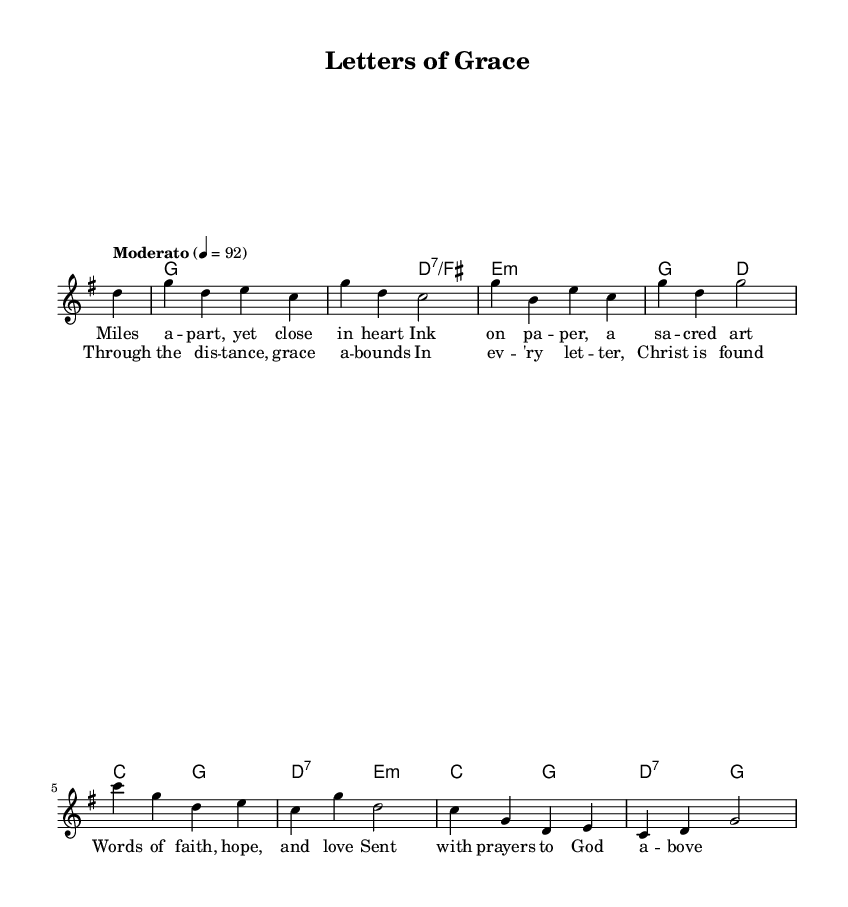What is the key signature of this music? The key signature is G major, indicated by one sharp (F#) at the beginning of the staff.
Answer: G major What is the time signature of the piece? The time signature is found at the beginning of the sheet music, showing that there are 4 beats in a measure represented by the 4/4 marking.
Answer: 4/4 What is the tempo marking of the song? The tempo marking is located in the introductory section and indicates a moderate speed. It specifies “Moderato” with a metronome marking of 92 beats per minute.
Answer: Moderato, 92 How many measures are there in the melody? To find the number of measures, count the vertical lines separating the sections of music in the melody line. The melody consists of 8 measures.
Answer: 8 What is the lyrical theme of the song? The lyrics focus on themes of friendship and God’s grace despite physical distance, as indicated in the verses and chorus provided.
Answer: Friendship and grace What instrument is primarily featured in this score? The score presents a staff with melody and chord names, indicating that it is designed for a voice or possibly an instrument playing the melody line.
Answer: Voice In which part of the song are the chorus lyrics introduced? The chorus lyrics are introduced after the verses and are indicated as separate lyrical sections in the score, following the first verse.
Answer: After the verses 